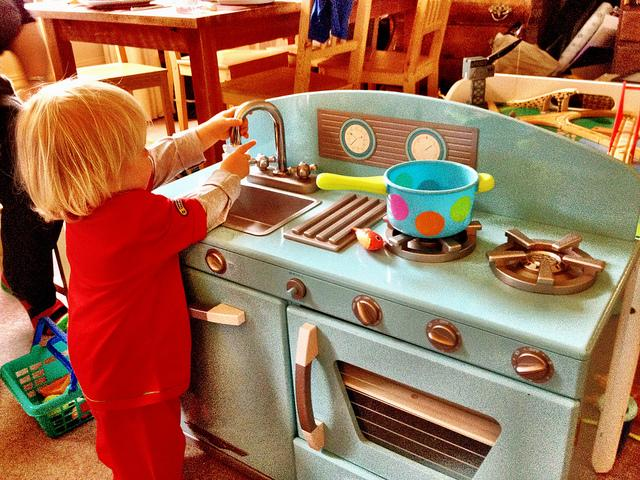What will come out of the sink? water 